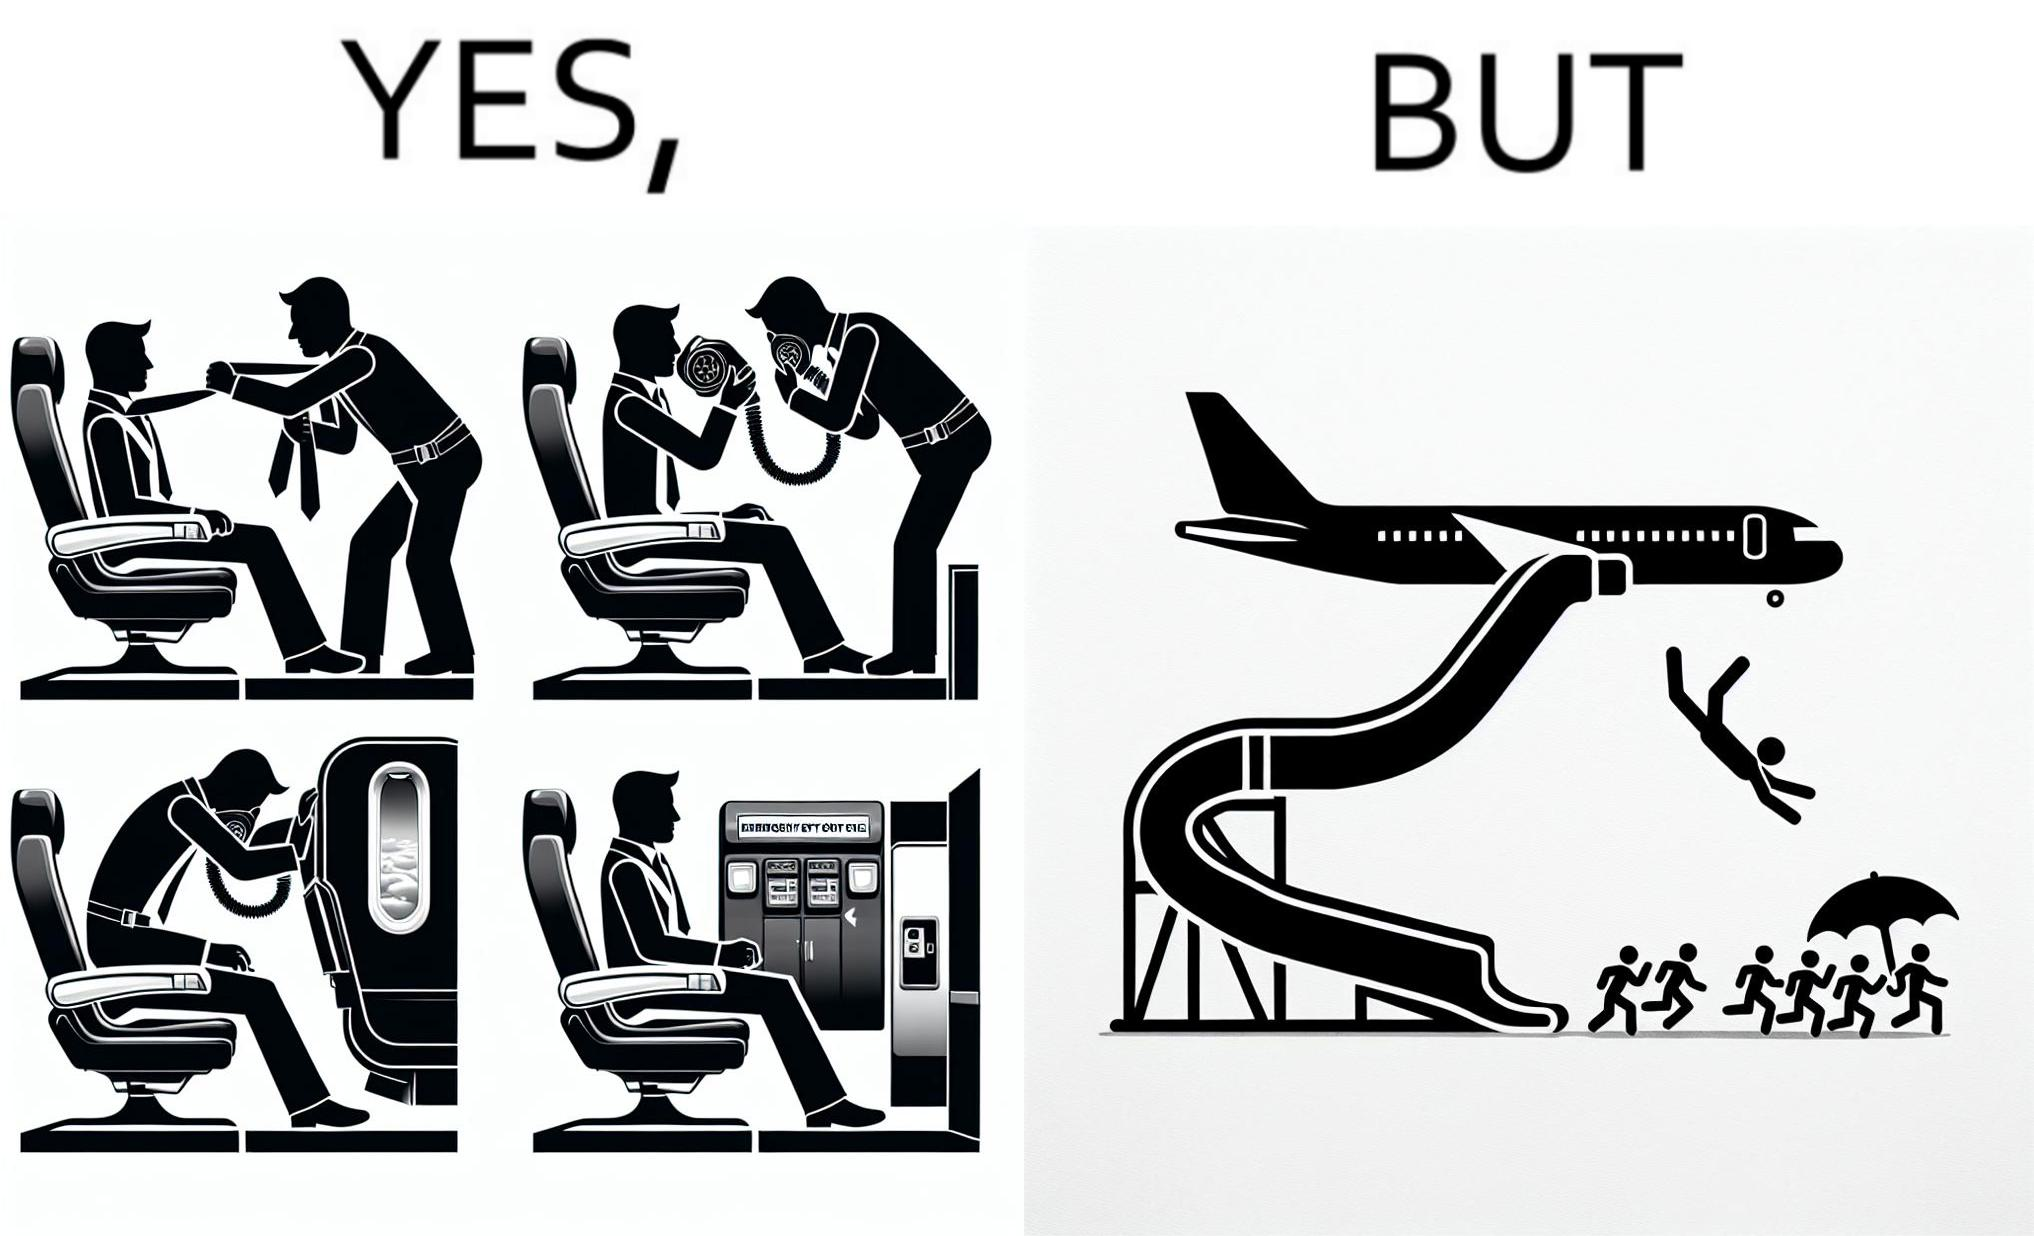Why is this image considered satirical? These images are funny since it shows how we are taught emergency procedures to follow in case of an accident while in an airplane but how none of them work if the plane is still in air 